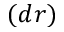<formula> <loc_0><loc_0><loc_500><loc_500>( d r )</formula> 